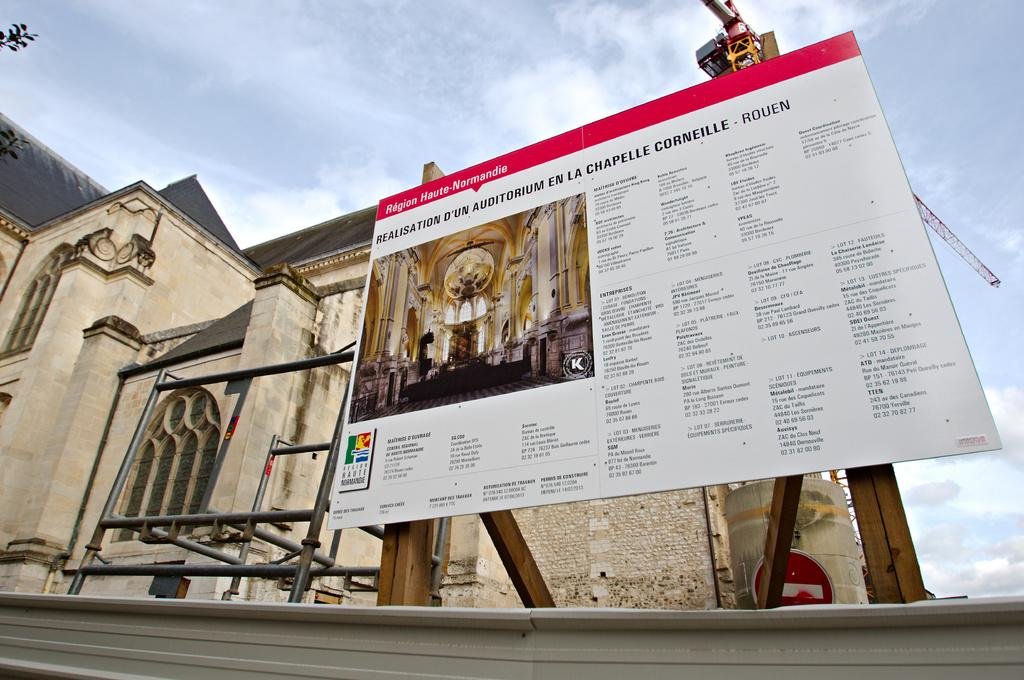<image>
Create a compact narrative representing the image presented. Region Haute-Normandie remodel sign sits near a church 